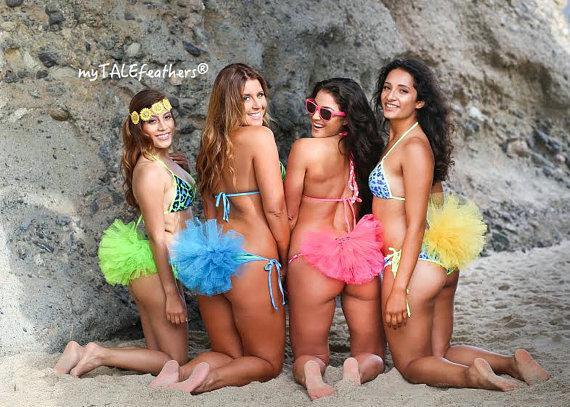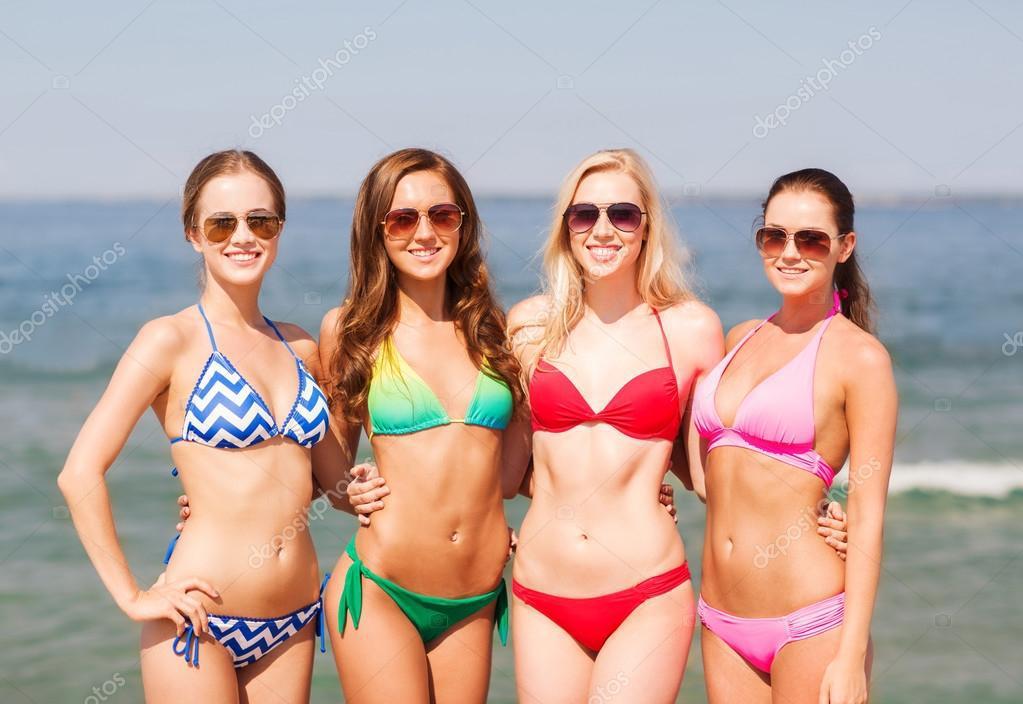The first image is the image on the left, the second image is the image on the right. For the images displayed, is the sentence "One image shows four bikini models in sunglasses standing in front of the ocean." factually correct? Answer yes or no. Yes. The first image is the image on the left, the second image is the image on the right. Examine the images to the left and right. Is the description "There are eight or less women." accurate? Answer yes or no. Yes. 